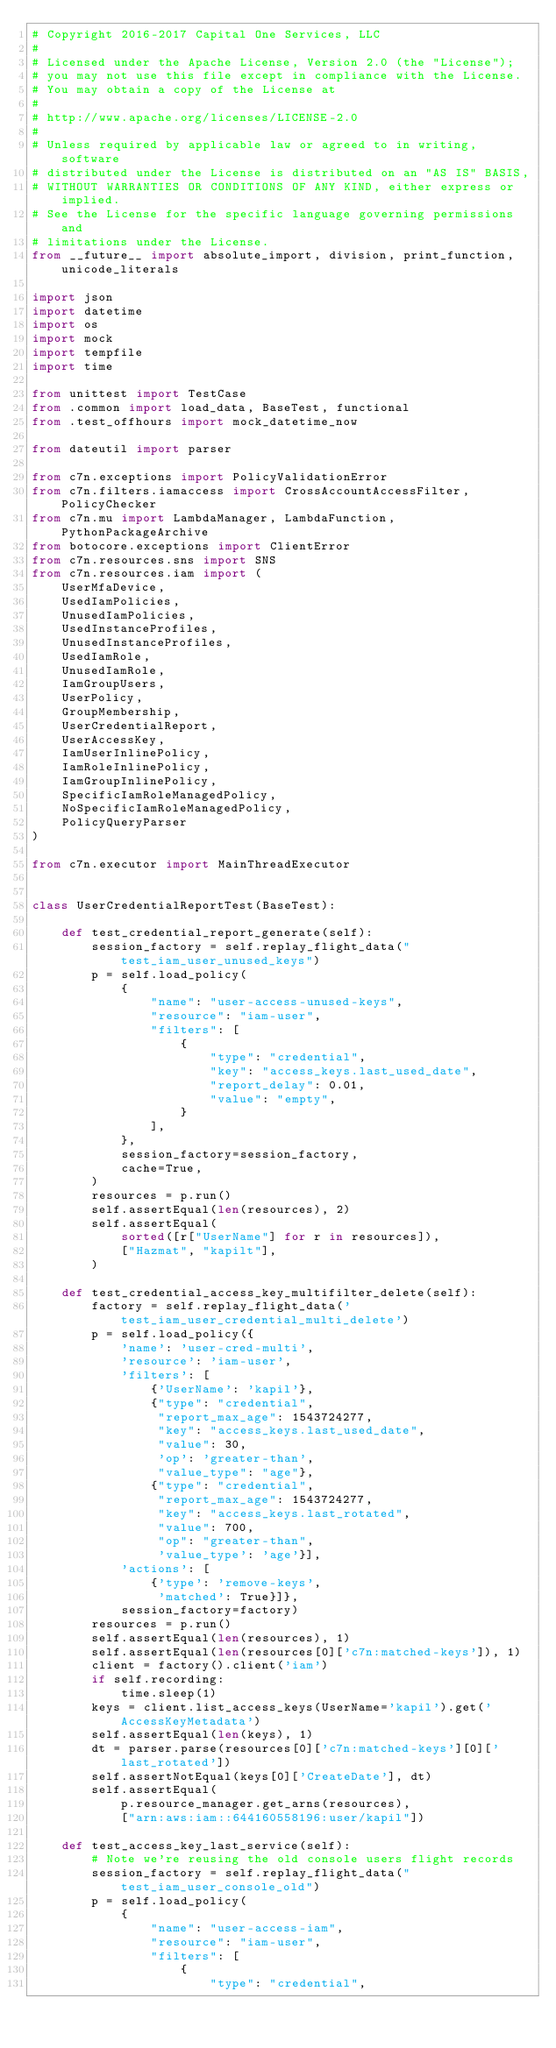Convert code to text. <code><loc_0><loc_0><loc_500><loc_500><_Python_># Copyright 2016-2017 Capital One Services, LLC
#
# Licensed under the Apache License, Version 2.0 (the "License");
# you may not use this file except in compliance with the License.
# You may obtain a copy of the License at
#
# http://www.apache.org/licenses/LICENSE-2.0
#
# Unless required by applicable law or agreed to in writing, software
# distributed under the License is distributed on an "AS IS" BASIS,
# WITHOUT WARRANTIES OR CONDITIONS OF ANY KIND, either express or implied.
# See the License for the specific language governing permissions and
# limitations under the License.
from __future__ import absolute_import, division, print_function, unicode_literals

import json
import datetime
import os
import mock
import tempfile
import time

from unittest import TestCase
from .common import load_data, BaseTest, functional
from .test_offhours import mock_datetime_now

from dateutil import parser

from c7n.exceptions import PolicyValidationError
from c7n.filters.iamaccess import CrossAccountAccessFilter, PolicyChecker
from c7n.mu import LambdaManager, LambdaFunction, PythonPackageArchive
from botocore.exceptions import ClientError
from c7n.resources.sns import SNS
from c7n.resources.iam import (
    UserMfaDevice,
    UsedIamPolicies,
    UnusedIamPolicies,
    UsedInstanceProfiles,
    UnusedInstanceProfiles,
    UsedIamRole,
    UnusedIamRole,
    IamGroupUsers,
    UserPolicy,
    GroupMembership,
    UserCredentialReport,
    UserAccessKey,
    IamUserInlinePolicy,
    IamRoleInlinePolicy,
    IamGroupInlinePolicy,
    SpecificIamRoleManagedPolicy,
    NoSpecificIamRoleManagedPolicy,
    PolicyQueryParser
)

from c7n.executor import MainThreadExecutor


class UserCredentialReportTest(BaseTest):

    def test_credential_report_generate(self):
        session_factory = self.replay_flight_data("test_iam_user_unused_keys")
        p = self.load_policy(
            {
                "name": "user-access-unused-keys",
                "resource": "iam-user",
                "filters": [
                    {
                        "type": "credential",
                        "key": "access_keys.last_used_date",
                        "report_delay": 0.01,
                        "value": "empty",
                    }
                ],
            },
            session_factory=session_factory,
            cache=True,
        )
        resources = p.run()
        self.assertEqual(len(resources), 2)
        self.assertEqual(
            sorted([r["UserName"] for r in resources]),
            ["Hazmat", "kapilt"],
        )

    def test_credential_access_key_multifilter_delete(self):
        factory = self.replay_flight_data('test_iam_user_credential_multi_delete')
        p = self.load_policy({
            'name': 'user-cred-multi',
            'resource': 'iam-user',
            'filters': [
                {'UserName': 'kapil'},
                {"type": "credential",
                 "report_max_age": 1543724277,
                 "key": "access_keys.last_used_date",
                 "value": 30,
                 'op': 'greater-than',
                 "value_type": "age"},
                {"type": "credential",
                 "report_max_age": 1543724277,
                 "key": "access_keys.last_rotated",
                 "value": 700,
                 "op": "greater-than",
                 'value_type': 'age'}],
            'actions': [
                {'type': 'remove-keys',
                 'matched': True}]},
            session_factory=factory)
        resources = p.run()
        self.assertEqual(len(resources), 1)
        self.assertEqual(len(resources[0]['c7n:matched-keys']), 1)
        client = factory().client('iam')
        if self.recording:
            time.sleep(1)
        keys = client.list_access_keys(UserName='kapil').get('AccessKeyMetadata')
        self.assertEqual(len(keys), 1)
        dt = parser.parse(resources[0]['c7n:matched-keys'][0]['last_rotated'])
        self.assertNotEqual(keys[0]['CreateDate'], dt)
        self.assertEqual(
            p.resource_manager.get_arns(resources),
            ["arn:aws:iam::644160558196:user/kapil"])

    def test_access_key_last_service(self):
        # Note we're reusing the old console users flight records
        session_factory = self.replay_flight_data("test_iam_user_console_old")
        p = self.load_policy(
            {
                "name": "user-access-iam",
                "resource": "iam-user",
                "filters": [
                    {
                        "type": "credential",</code> 